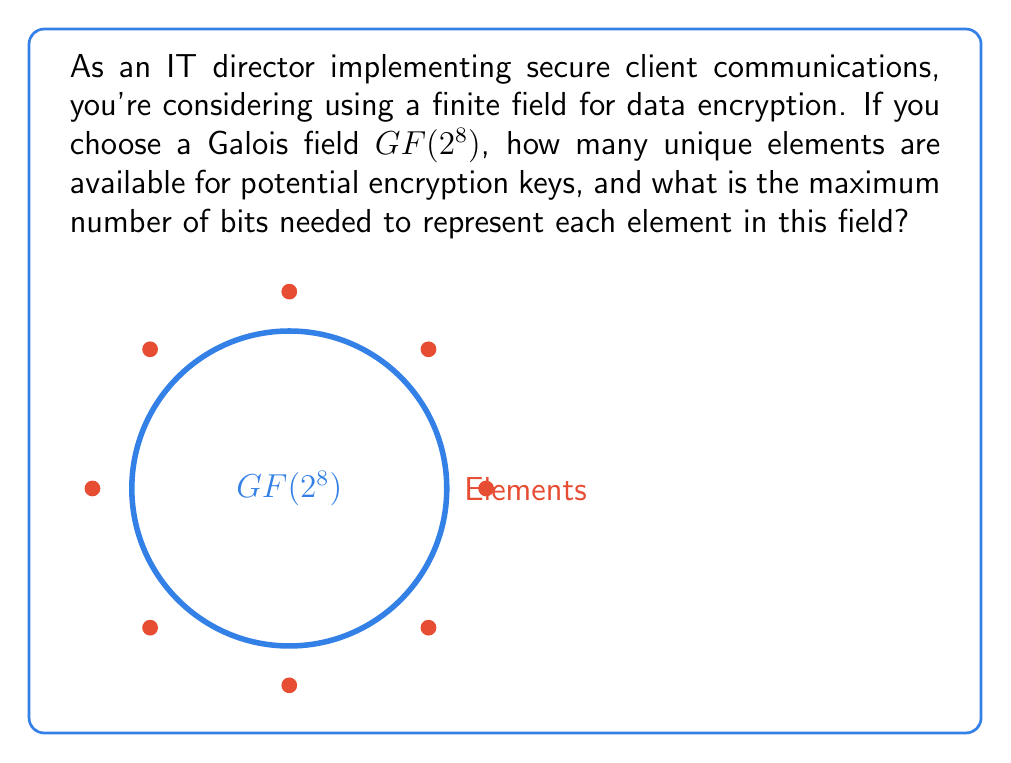Can you answer this question? To solve this problem, we need to understand the properties of Galois fields:

1. A Galois field $GF(p^n)$ has $p^n$ elements, where $p$ is prime and $n$ is a positive integer.

2. In this case, we have $GF(2^8)$, so $p = 2$ and $n = 8$.

3. Number of unique elements:
   $$\text{Number of elements} = 2^8 = 256$$

4. To determine the number of bits needed to represent each element:
   - We need to find the smallest integer $m$ such that $2^m \geq 256$
   - This is equivalent to solving: $m = \lceil \log_2(256) \rceil$
   - $\log_2(256) = 8$
   - Therefore, $m = 8$

5. Each element in $GF(2^8)$ can be represented as a polynomial of degree at most 7 over $GF(2)$, which corresponds to an 8-bit binary number.
Answer: 256 elements; 8 bits 